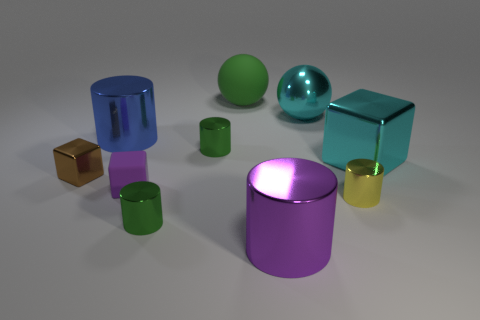If you had to guess, what material do these objects look like they're made from? Based on the reflections and the sheen on the surfaces, the objects appear to be rendered as if they're made of glass or a highly polished metal. This gives them an elegant and high-quality appearance that would stand out in a minimalist or contemporary setting. 